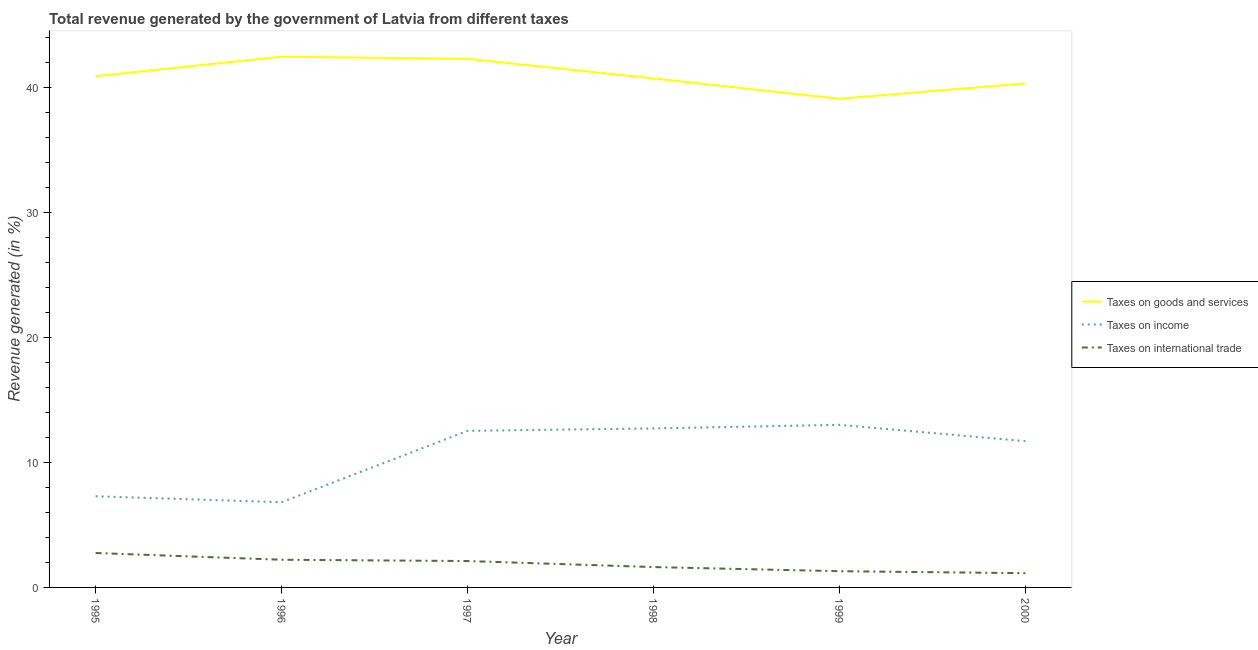How many different coloured lines are there?
Your response must be concise. 3. Does the line corresponding to percentage of revenue generated by taxes on goods and services intersect with the line corresponding to percentage of revenue generated by taxes on income?
Your answer should be very brief. No. Is the number of lines equal to the number of legend labels?
Give a very brief answer. Yes. What is the percentage of revenue generated by tax on international trade in 1998?
Make the answer very short. 1.63. Across all years, what is the maximum percentage of revenue generated by tax on international trade?
Provide a succinct answer. 2.75. Across all years, what is the minimum percentage of revenue generated by tax on international trade?
Make the answer very short. 1.14. In which year was the percentage of revenue generated by taxes on goods and services maximum?
Offer a very short reply. 1996. What is the total percentage of revenue generated by taxes on goods and services in the graph?
Offer a very short reply. 245.81. What is the difference between the percentage of revenue generated by tax on international trade in 1996 and that in 2000?
Offer a terse response. 1.07. What is the difference between the percentage of revenue generated by taxes on income in 1999 and the percentage of revenue generated by tax on international trade in 1996?
Your answer should be compact. 10.79. What is the average percentage of revenue generated by taxes on goods and services per year?
Your response must be concise. 40.97. In the year 1996, what is the difference between the percentage of revenue generated by taxes on goods and services and percentage of revenue generated by tax on international trade?
Give a very brief answer. 40.25. In how many years, is the percentage of revenue generated by tax on international trade greater than 16 %?
Your answer should be compact. 0. What is the ratio of the percentage of revenue generated by taxes on goods and services in 1997 to that in 1999?
Your answer should be very brief. 1.08. Is the percentage of revenue generated by taxes on goods and services in 1998 less than that in 1999?
Make the answer very short. No. What is the difference between the highest and the second highest percentage of revenue generated by tax on international trade?
Offer a terse response. 0.54. What is the difference between the highest and the lowest percentage of revenue generated by taxes on income?
Provide a succinct answer. 6.19. Is it the case that in every year, the sum of the percentage of revenue generated by taxes on goods and services and percentage of revenue generated by taxes on income is greater than the percentage of revenue generated by tax on international trade?
Make the answer very short. Yes. Is the percentage of revenue generated by taxes on goods and services strictly greater than the percentage of revenue generated by tax on international trade over the years?
Give a very brief answer. Yes. Is the percentage of revenue generated by tax on international trade strictly less than the percentage of revenue generated by taxes on goods and services over the years?
Your answer should be compact. Yes. How many years are there in the graph?
Provide a short and direct response. 6. What is the difference between two consecutive major ticks on the Y-axis?
Make the answer very short. 10. How many legend labels are there?
Offer a very short reply. 3. How are the legend labels stacked?
Make the answer very short. Vertical. What is the title of the graph?
Keep it short and to the point. Total revenue generated by the government of Latvia from different taxes. What is the label or title of the Y-axis?
Offer a very short reply. Revenue generated (in %). What is the Revenue generated (in %) in Taxes on goods and services in 1995?
Give a very brief answer. 40.9. What is the Revenue generated (in %) of Taxes on income in 1995?
Make the answer very short. 7.29. What is the Revenue generated (in %) of Taxes on international trade in 1995?
Provide a succinct answer. 2.75. What is the Revenue generated (in %) in Taxes on goods and services in 1996?
Ensure brevity in your answer.  42.46. What is the Revenue generated (in %) in Taxes on income in 1996?
Your answer should be very brief. 6.81. What is the Revenue generated (in %) of Taxes on international trade in 1996?
Offer a terse response. 2.21. What is the Revenue generated (in %) in Taxes on goods and services in 1997?
Ensure brevity in your answer.  42.29. What is the Revenue generated (in %) of Taxes on income in 1997?
Provide a succinct answer. 12.53. What is the Revenue generated (in %) of Taxes on international trade in 1997?
Provide a short and direct response. 2.11. What is the Revenue generated (in %) of Taxes on goods and services in 1998?
Your answer should be very brief. 40.73. What is the Revenue generated (in %) in Taxes on income in 1998?
Your response must be concise. 12.72. What is the Revenue generated (in %) of Taxes on international trade in 1998?
Your response must be concise. 1.63. What is the Revenue generated (in %) in Taxes on goods and services in 1999?
Keep it short and to the point. 39.1. What is the Revenue generated (in %) in Taxes on income in 1999?
Your response must be concise. 13.01. What is the Revenue generated (in %) in Taxes on international trade in 1999?
Offer a very short reply. 1.3. What is the Revenue generated (in %) in Taxes on goods and services in 2000?
Make the answer very short. 40.33. What is the Revenue generated (in %) in Taxes on income in 2000?
Your answer should be compact. 11.7. What is the Revenue generated (in %) in Taxes on international trade in 2000?
Offer a very short reply. 1.14. Across all years, what is the maximum Revenue generated (in %) of Taxes on goods and services?
Ensure brevity in your answer.  42.46. Across all years, what is the maximum Revenue generated (in %) in Taxes on income?
Your response must be concise. 13.01. Across all years, what is the maximum Revenue generated (in %) of Taxes on international trade?
Ensure brevity in your answer.  2.75. Across all years, what is the minimum Revenue generated (in %) of Taxes on goods and services?
Keep it short and to the point. 39.1. Across all years, what is the minimum Revenue generated (in %) of Taxes on income?
Provide a succinct answer. 6.81. Across all years, what is the minimum Revenue generated (in %) of Taxes on international trade?
Give a very brief answer. 1.14. What is the total Revenue generated (in %) of Taxes on goods and services in the graph?
Offer a terse response. 245.81. What is the total Revenue generated (in %) of Taxes on income in the graph?
Keep it short and to the point. 64.06. What is the total Revenue generated (in %) of Taxes on international trade in the graph?
Offer a very short reply. 11.15. What is the difference between the Revenue generated (in %) in Taxes on goods and services in 1995 and that in 1996?
Offer a terse response. -1.56. What is the difference between the Revenue generated (in %) in Taxes on income in 1995 and that in 1996?
Ensure brevity in your answer.  0.48. What is the difference between the Revenue generated (in %) in Taxes on international trade in 1995 and that in 1996?
Your response must be concise. 0.54. What is the difference between the Revenue generated (in %) in Taxes on goods and services in 1995 and that in 1997?
Provide a short and direct response. -1.39. What is the difference between the Revenue generated (in %) in Taxes on income in 1995 and that in 1997?
Keep it short and to the point. -5.23. What is the difference between the Revenue generated (in %) of Taxes on international trade in 1995 and that in 1997?
Your answer should be very brief. 0.64. What is the difference between the Revenue generated (in %) of Taxes on goods and services in 1995 and that in 1998?
Provide a short and direct response. 0.17. What is the difference between the Revenue generated (in %) in Taxes on income in 1995 and that in 1998?
Ensure brevity in your answer.  -5.42. What is the difference between the Revenue generated (in %) in Taxes on international trade in 1995 and that in 1998?
Your response must be concise. 1.12. What is the difference between the Revenue generated (in %) of Taxes on goods and services in 1995 and that in 1999?
Provide a short and direct response. 1.8. What is the difference between the Revenue generated (in %) in Taxes on income in 1995 and that in 1999?
Make the answer very short. -5.71. What is the difference between the Revenue generated (in %) in Taxes on international trade in 1995 and that in 1999?
Give a very brief answer. 1.46. What is the difference between the Revenue generated (in %) in Taxes on goods and services in 1995 and that in 2000?
Provide a short and direct response. 0.57. What is the difference between the Revenue generated (in %) in Taxes on income in 1995 and that in 2000?
Ensure brevity in your answer.  -4.41. What is the difference between the Revenue generated (in %) in Taxes on international trade in 1995 and that in 2000?
Provide a succinct answer. 1.61. What is the difference between the Revenue generated (in %) in Taxes on goods and services in 1996 and that in 1997?
Ensure brevity in your answer.  0.17. What is the difference between the Revenue generated (in %) of Taxes on income in 1996 and that in 1997?
Provide a succinct answer. -5.71. What is the difference between the Revenue generated (in %) of Taxes on international trade in 1996 and that in 1997?
Offer a terse response. 0.1. What is the difference between the Revenue generated (in %) in Taxes on goods and services in 1996 and that in 1998?
Your answer should be very brief. 1.74. What is the difference between the Revenue generated (in %) of Taxes on income in 1996 and that in 1998?
Offer a terse response. -5.9. What is the difference between the Revenue generated (in %) of Taxes on international trade in 1996 and that in 1998?
Your response must be concise. 0.59. What is the difference between the Revenue generated (in %) of Taxes on goods and services in 1996 and that in 1999?
Provide a succinct answer. 3.36. What is the difference between the Revenue generated (in %) of Taxes on income in 1996 and that in 1999?
Your response must be concise. -6.19. What is the difference between the Revenue generated (in %) in Taxes on international trade in 1996 and that in 1999?
Your response must be concise. 0.92. What is the difference between the Revenue generated (in %) of Taxes on goods and services in 1996 and that in 2000?
Make the answer very short. 2.14. What is the difference between the Revenue generated (in %) of Taxes on income in 1996 and that in 2000?
Give a very brief answer. -4.89. What is the difference between the Revenue generated (in %) in Taxes on international trade in 1996 and that in 2000?
Give a very brief answer. 1.07. What is the difference between the Revenue generated (in %) of Taxes on goods and services in 1997 and that in 1998?
Give a very brief answer. 1.57. What is the difference between the Revenue generated (in %) of Taxes on income in 1997 and that in 1998?
Keep it short and to the point. -0.19. What is the difference between the Revenue generated (in %) in Taxes on international trade in 1997 and that in 1998?
Offer a very short reply. 0.48. What is the difference between the Revenue generated (in %) of Taxes on goods and services in 1997 and that in 1999?
Provide a short and direct response. 3.2. What is the difference between the Revenue generated (in %) in Taxes on income in 1997 and that in 1999?
Offer a very short reply. -0.48. What is the difference between the Revenue generated (in %) of Taxes on international trade in 1997 and that in 1999?
Give a very brief answer. 0.81. What is the difference between the Revenue generated (in %) in Taxes on goods and services in 1997 and that in 2000?
Provide a short and direct response. 1.97. What is the difference between the Revenue generated (in %) of Taxes on income in 1997 and that in 2000?
Provide a short and direct response. 0.83. What is the difference between the Revenue generated (in %) of Taxes on international trade in 1997 and that in 2000?
Provide a succinct answer. 0.97. What is the difference between the Revenue generated (in %) in Taxes on goods and services in 1998 and that in 1999?
Your answer should be compact. 1.63. What is the difference between the Revenue generated (in %) of Taxes on income in 1998 and that in 1999?
Offer a very short reply. -0.29. What is the difference between the Revenue generated (in %) of Taxes on international trade in 1998 and that in 1999?
Provide a succinct answer. 0.33. What is the difference between the Revenue generated (in %) in Taxes on goods and services in 1998 and that in 2000?
Give a very brief answer. 0.4. What is the difference between the Revenue generated (in %) of Taxes on income in 1998 and that in 2000?
Offer a terse response. 1.02. What is the difference between the Revenue generated (in %) in Taxes on international trade in 1998 and that in 2000?
Offer a terse response. 0.49. What is the difference between the Revenue generated (in %) of Taxes on goods and services in 1999 and that in 2000?
Ensure brevity in your answer.  -1.23. What is the difference between the Revenue generated (in %) in Taxes on income in 1999 and that in 2000?
Your response must be concise. 1.31. What is the difference between the Revenue generated (in %) in Taxes on international trade in 1999 and that in 2000?
Provide a succinct answer. 0.16. What is the difference between the Revenue generated (in %) of Taxes on goods and services in 1995 and the Revenue generated (in %) of Taxes on income in 1996?
Make the answer very short. 34.09. What is the difference between the Revenue generated (in %) in Taxes on goods and services in 1995 and the Revenue generated (in %) in Taxes on international trade in 1996?
Provide a short and direct response. 38.69. What is the difference between the Revenue generated (in %) of Taxes on income in 1995 and the Revenue generated (in %) of Taxes on international trade in 1996?
Provide a short and direct response. 5.08. What is the difference between the Revenue generated (in %) in Taxes on goods and services in 1995 and the Revenue generated (in %) in Taxes on income in 1997?
Your response must be concise. 28.37. What is the difference between the Revenue generated (in %) in Taxes on goods and services in 1995 and the Revenue generated (in %) in Taxes on international trade in 1997?
Ensure brevity in your answer.  38.79. What is the difference between the Revenue generated (in %) in Taxes on income in 1995 and the Revenue generated (in %) in Taxes on international trade in 1997?
Your answer should be very brief. 5.18. What is the difference between the Revenue generated (in %) of Taxes on goods and services in 1995 and the Revenue generated (in %) of Taxes on income in 1998?
Provide a succinct answer. 28.18. What is the difference between the Revenue generated (in %) in Taxes on goods and services in 1995 and the Revenue generated (in %) in Taxes on international trade in 1998?
Your response must be concise. 39.27. What is the difference between the Revenue generated (in %) of Taxes on income in 1995 and the Revenue generated (in %) of Taxes on international trade in 1998?
Your response must be concise. 5.67. What is the difference between the Revenue generated (in %) of Taxes on goods and services in 1995 and the Revenue generated (in %) of Taxes on income in 1999?
Offer a terse response. 27.89. What is the difference between the Revenue generated (in %) of Taxes on goods and services in 1995 and the Revenue generated (in %) of Taxes on international trade in 1999?
Make the answer very short. 39.6. What is the difference between the Revenue generated (in %) of Taxes on income in 1995 and the Revenue generated (in %) of Taxes on international trade in 1999?
Make the answer very short. 6. What is the difference between the Revenue generated (in %) of Taxes on goods and services in 1995 and the Revenue generated (in %) of Taxes on income in 2000?
Provide a short and direct response. 29.2. What is the difference between the Revenue generated (in %) in Taxes on goods and services in 1995 and the Revenue generated (in %) in Taxes on international trade in 2000?
Provide a succinct answer. 39.76. What is the difference between the Revenue generated (in %) of Taxes on income in 1995 and the Revenue generated (in %) of Taxes on international trade in 2000?
Your response must be concise. 6.15. What is the difference between the Revenue generated (in %) of Taxes on goods and services in 1996 and the Revenue generated (in %) of Taxes on income in 1997?
Offer a very short reply. 29.93. What is the difference between the Revenue generated (in %) in Taxes on goods and services in 1996 and the Revenue generated (in %) in Taxes on international trade in 1997?
Give a very brief answer. 40.35. What is the difference between the Revenue generated (in %) in Taxes on income in 1996 and the Revenue generated (in %) in Taxes on international trade in 1997?
Your answer should be very brief. 4.7. What is the difference between the Revenue generated (in %) in Taxes on goods and services in 1996 and the Revenue generated (in %) in Taxes on income in 1998?
Ensure brevity in your answer.  29.74. What is the difference between the Revenue generated (in %) in Taxes on goods and services in 1996 and the Revenue generated (in %) in Taxes on international trade in 1998?
Keep it short and to the point. 40.83. What is the difference between the Revenue generated (in %) of Taxes on income in 1996 and the Revenue generated (in %) of Taxes on international trade in 1998?
Offer a terse response. 5.19. What is the difference between the Revenue generated (in %) in Taxes on goods and services in 1996 and the Revenue generated (in %) in Taxes on income in 1999?
Ensure brevity in your answer.  29.45. What is the difference between the Revenue generated (in %) of Taxes on goods and services in 1996 and the Revenue generated (in %) of Taxes on international trade in 1999?
Your answer should be very brief. 41.16. What is the difference between the Revenue generated (in %) of Taxes on income in 1996 and the Revenue generated (in %) of Taxes on international trade in 1999?
Ensure brevity in your answer.  5.52. What is the difference between the Revenue generated (in %) of Taxes on goods and services in 1996 and the Revenue generated (in %) of Taxes on income in 2000?
Your answer should be compact. 30.76. What is the difference between the Revenue generated (in %) of Taxes on goods and services in 1996 and the Revenue generated (in %) of Taxes on international trade in 2000?
Provide a short and direct response. 41.32. What is the difference between the Revenue generated (in %) of Taxes on income in 1996 and the Revenue generated (in %) of Taxes on international trade in 2000?
Your response must be concise. 5.68. What is the difference between the Revenue generated (in %) of Taxes on goods and services in 1997 and the Revenue generated (in %) of Taxes on income in 1998?
Offer a terse response. 29.57. What is the difference between the Revenue generated (in %) in Taxes on goods and services in 1997 and the Revenue generated (in %) in Taxes on international trade in 1998?
Keep it short and to the point. 40.66. What is the difference between the Revenue generated (in %) of Taxes on income in 1997 and the Revenue generated (in %) of Taxes on international trade in 1998?
Give a very brief answer. 10.9. What is the difference between the Revenue generated (in %) of Taxes on goods and services in 1997 and the Revenue generated (in %) of Taxes on income in 1999?
Make the answer very short. 29.29. What is the difference between the Revenue generated (in %) in Taxes on goods and services in 1997 and the Revenue generated (in %) in Taxes on international trade in 1999?
Your response must be concise. 40.99. What is the difference between the Revenue generated (in %) in Taxes on income in 1997 and the Revenue generated (in %) in Taxes on international trade in 1999?
Your response must be concise. 11.23. What is the difference between the Revenue generated (in %) in Taxes on goods and services in 1997 and the Revenue generated (in %) in Taxes on income in 2000?
Provide a succinct answer. 30.59. What is the difference between the Revenue generated (in %) in Taxes on goods and services in 1997 and the Revenue generated (in %) in Taxes on international trade in 2000?
Offer a terse response. 41.15. What is the difference between the Revenue generated (in %) of Taxes on income in 1997 and the Revenue generated (in %) of Taxes on international trade in 2000?
Provide a short and direct response. 11.39. What is the difference between the Revenue generated (in %) of Taxes on goods and services in 1998 and the Revenue generated (in %) of Taxes on income in 1999?
Give a very brief answer. 27.72. What is the difference between the Revenue generated (in %) in Taxes on goods and services in 1998 and the Revenue generated (in %) in Taxes on international trade in 1999?
Provide a succinct answer. 39.43. What is the difference between the Revenue generated (in %) of Taxes on income in 1998 and the Revenue generated (in %) of Taxes on international trade in 1999?
Keep it short and to the point. 11.42. What is the difference between the Revenue generated (in %) in Taxes on goods and services in 1998 and the Revenue generated (in %) in Taxes on income in 2000?
Provide a short and direct response. 29.02. What is the difference between the Revenue generated (in %) in Taxes on goods and services in 1998 and the Revenue generated (in %) in Taxes on international trade in 2000?
Offer a very short reply. 39.59. What is the difference between the Revenue generated (in %) of Taxes on income in 1998 and the Revenue generated (in %) of Taxes on international trade in 2000?
Provide a succinct answer. 11.58. What is the difference between the Revenue generated (in %) of Taxes on goods and services in 1999 and the Revenue generated (in %) of Taxes on income in 2000?
Offer a very short reply. 27.4. What is the difference between the Revenue generated (in %) in Taxes on goods and services in 1999 and the Revenue generated (in %) in Taxes on international trade in 2000?
Keep it short and to the point. 37.96. What is the difference between the Revenue generated (in %) of Taxes on income in 1999 and the Revenue generated (in %) of Taxes on international trade in 2000?
Ensure brevity in your answer.  11.87. What is the average Revenue generated (in %) of Taxes on goods and services per year?
Your response must be concise. 40.97. What is the average Revenue generated (in %) in Taxes on income per year?
Offer a very short reply. 10.68. What is the average Revenue generated (in %) of Taxes on international trade per year?
Your response must be concise. 1.86. In the year 1995, what is the difference between the Revenue generated (in %) in Taxes on goods and services and Revenue generated (in %) in Taxes on income?
Give a very brief answer. 33.61. In the year 1995, what is the difference between the Revenue generated (in %) in Taxes on goods and services and Revenue generated (in %) in Taxes on international trade?
Your answer should be compact. 38.15. In the year 1995, what is the difference between the Revenue generated (in %) of Taxes on income and Revenue generated (in %) of Taxes on international trade?
Provide a short and direct response. 4.54. In the year 1996, what is the difference between the Revenue generated (in %) in Taxes on goods and services and Revenue generated (in %) in Taxes on income?
Ensure brevity in your answer.  35.65. In the year 1996, what is the difference between the Revenue generated (in %) in Taxes on goods and services and Revenue generated (in %) in Taxes on international trade?
Offer a terse response. 40.25. In the year 1996, what is the difference between the Revenue generated (in %) in Taxes on income and Revenue generated (in %) in Taxes on international trade?
Provide a short and direct response. 4.6. In the year 1997, what is the difference between the Revenue generated (in %) in Taxes on goods and services and Revenue generated (in %) in Taxes on income?
Your answer should be compact. 29.77. In the year 1997, what is the difference between the Revenue generated (in %) of Taxes on goods and services and Revenue generated (in %) of Taxes on international trade?
Your answer should be very brief. 40.18. In the year 1997, what is the difference between the Revenue generated (in %) of Taxes on income and Revenue generated (in %) of Taxes on international trade?
Your answer should be compact. 10.42. In the year 1998, what is the difference between the Revenue generated (in %) of Taxes on goods and services and Revenue generated (in %) of Taxes on income?
Offer a terse response. 28.01. In the year 1998, what is the difference between the Revenue generated (in %) of Taxes on goods and services and Revenue generated (in %) of Taxes on international trade?
Your answer should be very brief. 39.1. In the year 1998, what is the difference between the Revenue generated (in %) of Taxes on income and Revenue generated (in %) of Taxes on international trade?
Your response must be concise. 11.09. In the year 1999, what is the difference between the Revenue generated (in %) of Taxes on goods and services and Revenue generated (in %) of Taxes on income?
Offer a terse response. 26.09. In the year 1999, what is the difference between the Revenue generated (in %) of Taxes on goods and services and Revenue generated (in %) of Taxes on international trade?
Give a very brief answer. 37.8. In the year 1999, what is the difference between the Revenue generated (in %) of Taxes on income and Revenue generated (in %) of Taxes on international trade?
Offer a terse response. 11.71. In the year 2000, what is the difference between the Revenue generated (in %) in Taxes on goods and services and Revenue generated (in %) in Taxes on income?
Your response must be concise. 28.63. In the year 2000, what is the difference between the Revenue generated (in %) in Taxes on goods and services and Revenue generated (in %) in Taxes on international trade?
Offer a terse response. 39.19. In the year 2000, what is the difference between the Revenue generated (in %) in Taxes on income and Revenue generated (in %) in Taxes on international trade?
Provide a succinct answer. 10.56. What is the ratio of the Revenue generated (in %) in Taxes on goods and services in 1995 to that in 1996?
Make the answer very short. 0.96. What is the ratio of the Revenue generated (in %) of Taxes on income in 1995 to that in 1996?
Offer a terse response. 1.07. What is the ratio of the Revenue generated (in %) in Taxes on international trade in 1995 to that in 1996?
Your response must be concise. 1.24. What is the ratio of the Revenue generated (in %) of Taxes on goods and services in 1995 to that in 1997?
Ensure brevity in your answer.  0.97. What is the ratio of the Revenue generated (in %) in Taxes on income in 1995 to that in 1997?
Offer a terse response. 0.58. What is the ratio of the Revenue generated (in %) of Taxes on international trade in 1995 to that in 1997?
Keep it short and to the point. 1.3. What is the ratio of the Revenue generated (in %) of Taxes on income in 1995 to that in 1998?
Make the answer very short. 0.57. What is the ratio of the Revenue generated (in %) in Taxes on international trade in 1995 to that in 1998?
Provide a short and direct response. 1.69. What is the ratio of the Revenue generated (in %) in Taxes on goods and services in 1995 to that in 1999?
Provide a succinct answer. 1.05. What is the ratio of the Revenue generated (in %) of Taxes on income in 1995 to that in 1999?
Your answer should be compact. 0.56. What is the ratio of the Revenue generated (in %) in Taxes on international trade in 1995 to that in 1999?
Your answer should be very brief. 2.12. What is the ratio of the Revenue generated (in %) in Taxes on goods and services in 1995 to that in 2000?
Your response must be concise. 1.01. What is the ratio of the Revenue generated (in %) of Taxes on income in 1995 to that in 2000?
Offer a very short reply. 0.62. What is the ratio of the Revenue generated (in %) of Taxes on international trade in 1995 to that in 2000?
Provide a short and direct response. 2.42. What is the ratio of the Revenue generated (in %) of Taxes on goods and services in 1996 to that in 1997?
Offer a very short reply. 1. What is the ratio of the Revenue generated (in %) of Taxes on income in 1996 to that in 1997?
Give a very brief answer. 0.54. What is the ratio of the Revenue generated (in %) of Taxes on international trade in 1996 to that in 1997?
Your answer should be compact. 1.05. What is the ratio of the Revenue generated (in %) of Taxes on goods and services in 1996 to that in 1998?
Give a very brief answer. 1.04. What is the ratio of the Revenue generated (in %) of Taxes on income in 1996 to that in 1998?
Ensure brevity in your answer.  0.54. What is the ratio of the Revenue generated (in %) in Taxes on international trade in 1996 to that in 1998?
Keep it short and to the point. 1.36. What is the ratio of the Revenue generated (in %) in Taxes on goods and services in 1996 to that in 1999?
Ensure brevity in your answer.  1.09. What is the ratio of the Revenue generated (in %) of Taxes on income in 1996 to that in 1999?
Provide a short and direct response. 0.52. What is the ratio of the Revenue generated (in %) of Taxes on international trade in 1996 to that in 1999?
Your response must be concise. 1.71. What is the ratio of the Revenue generated (in %) of Taxes on goods and services in 1996 to that in 2000?
Keep it short and to the point. 1.05. What is the ratio of the Revenue generated (in %) of Taxes on income in 1996 to that in 2000?
Ensure brevity in your answer.  0.58. What is the ratio of the Revenue generated (in %) in Taxes on international trade in 1996 to that in 2000?
Your response must be concise. 1.94. What is the ratio of the Revenue generated (in %) of Taxes on income in 1997 to that in 1998?
Your answer should be very brief. 0.98. What is the ratio of the Revenue generated (in %) of Taxes on international trade in 1997 to that in 1998?
Your response must be concise. 1.3. What is the ratio of the Revenue generated (in %) of Taxes on goods and services in 1997 to that in 1999?
Offer a terse response. 1.08. What is the ratio of the Revenue generated (in %) in Taxes on income in 1997 to that in 1999?
Give a very brief answer. 0.96. What is the ratio of the Revenue generated (in %) of Taxes on international trade in 1997 to that in 1999?
Give a very brief answer. 1.63. What is the ratio of the Revenue generated (in %) in Taxes on goods and services in 1997 to that in 2000?
Provide a short and direct response. 1.05. What is the ratio of the Revenue generated (in %) of Taxes on income in 1997 to that in 2000?
Provide a succinct answer. 1.07. What is the ratio of the Revenue generated (in %) of Taxes on international trade in 1997 to that in 2000?
Make the answer very short. 1.85. What is the ratio of the Revenue generated (in %) of Taxes on goods and services in 1998 to that in 1999?
Provide a succinct answer. 1.04. What is the ratio of the Revenue generated (in %) of Taxes on income in 1998 to that in 1999?
Your answer should be compact. 0.98. What is the ratio of the Revenue generated (in %) of Taxes on international trade in 1998 to that in 1999?
Give a very brief answer. 1.25. What is the ratio of the Revenue generated (in %) in Taxes on goods and services in 1998 to that in 2000?
Provide a short and direct response. 1.01. What is the ratio of the Revenue generated (in %) in Taxes on income in 1998 to that in 2000?
Make the answer very short. 1.09. What is the ratio of the Revenue generated (in %) in Taxes on international trade in 1998 to that in 2000?
Your answer should be compact. 1.43. What is the ratio of the Revenue generated (in %) of Taxes on goods and services in 1999 to that in 2000?
Offer a very short reply. 0.97. What is the ratio of the Revenue generated (in %) of Taxes on income in 1999 to that in 2000?
Your answer should be very brief. 1.11. What is the ratio of the Revenue generated (in %) of Taxes on international trade in 1999 to that in 2000?
Your answer should be very brief. 1.14. What is the difference between the highest and the second highest Revenue generated (in %) in Taxes on goods and services?
Your answer should be compact. 0.17. What is the difference between the highest and the second highest Revenue generated (in %) of Taxes on income?
Keep it short and to the point. 0.29. What is the difference between the highest and the second highest Revenue generated (in %) in Taxes on international trade?
Give a very brief answer. 0.54. What is the difference between the highest and the lowest Revenue generated (in %) in Taxes on goods and services?
Make the answer very short. 3.36. What is the difference between the highest and the lowest Revenue generated (in %) in Taxes on income?
Keep it short and to the point. 6.19. What is the difference between the highest and the lowest Revenue generated (in %) of Taxes on international trade?
Offer a terse response. 1.61. 